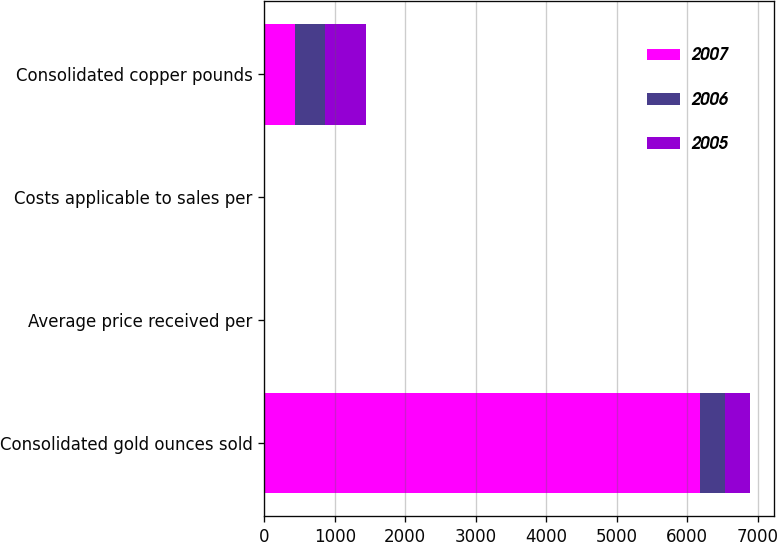<chart> <loc_0><loc_0><loc_500><loc_500><stacked_bar_chart><ecel><fcel>Consolidated gold ounces sold<fcel>Average price received per<fcel>Costs applicable to sales per<fcel>Consolidated copper pounds<nl><fcel>2007<fcel>6184<fcel>2.86<fcel>1.1<fcel>428<nl><fcel>2006<fcel>354.5<fcel>1.54<fcel>0.71<fcel>435<nl><fcel>2005<fcel>354.5<fcel>1.17<fcel>0.53<fcel>573<nl></chart> 